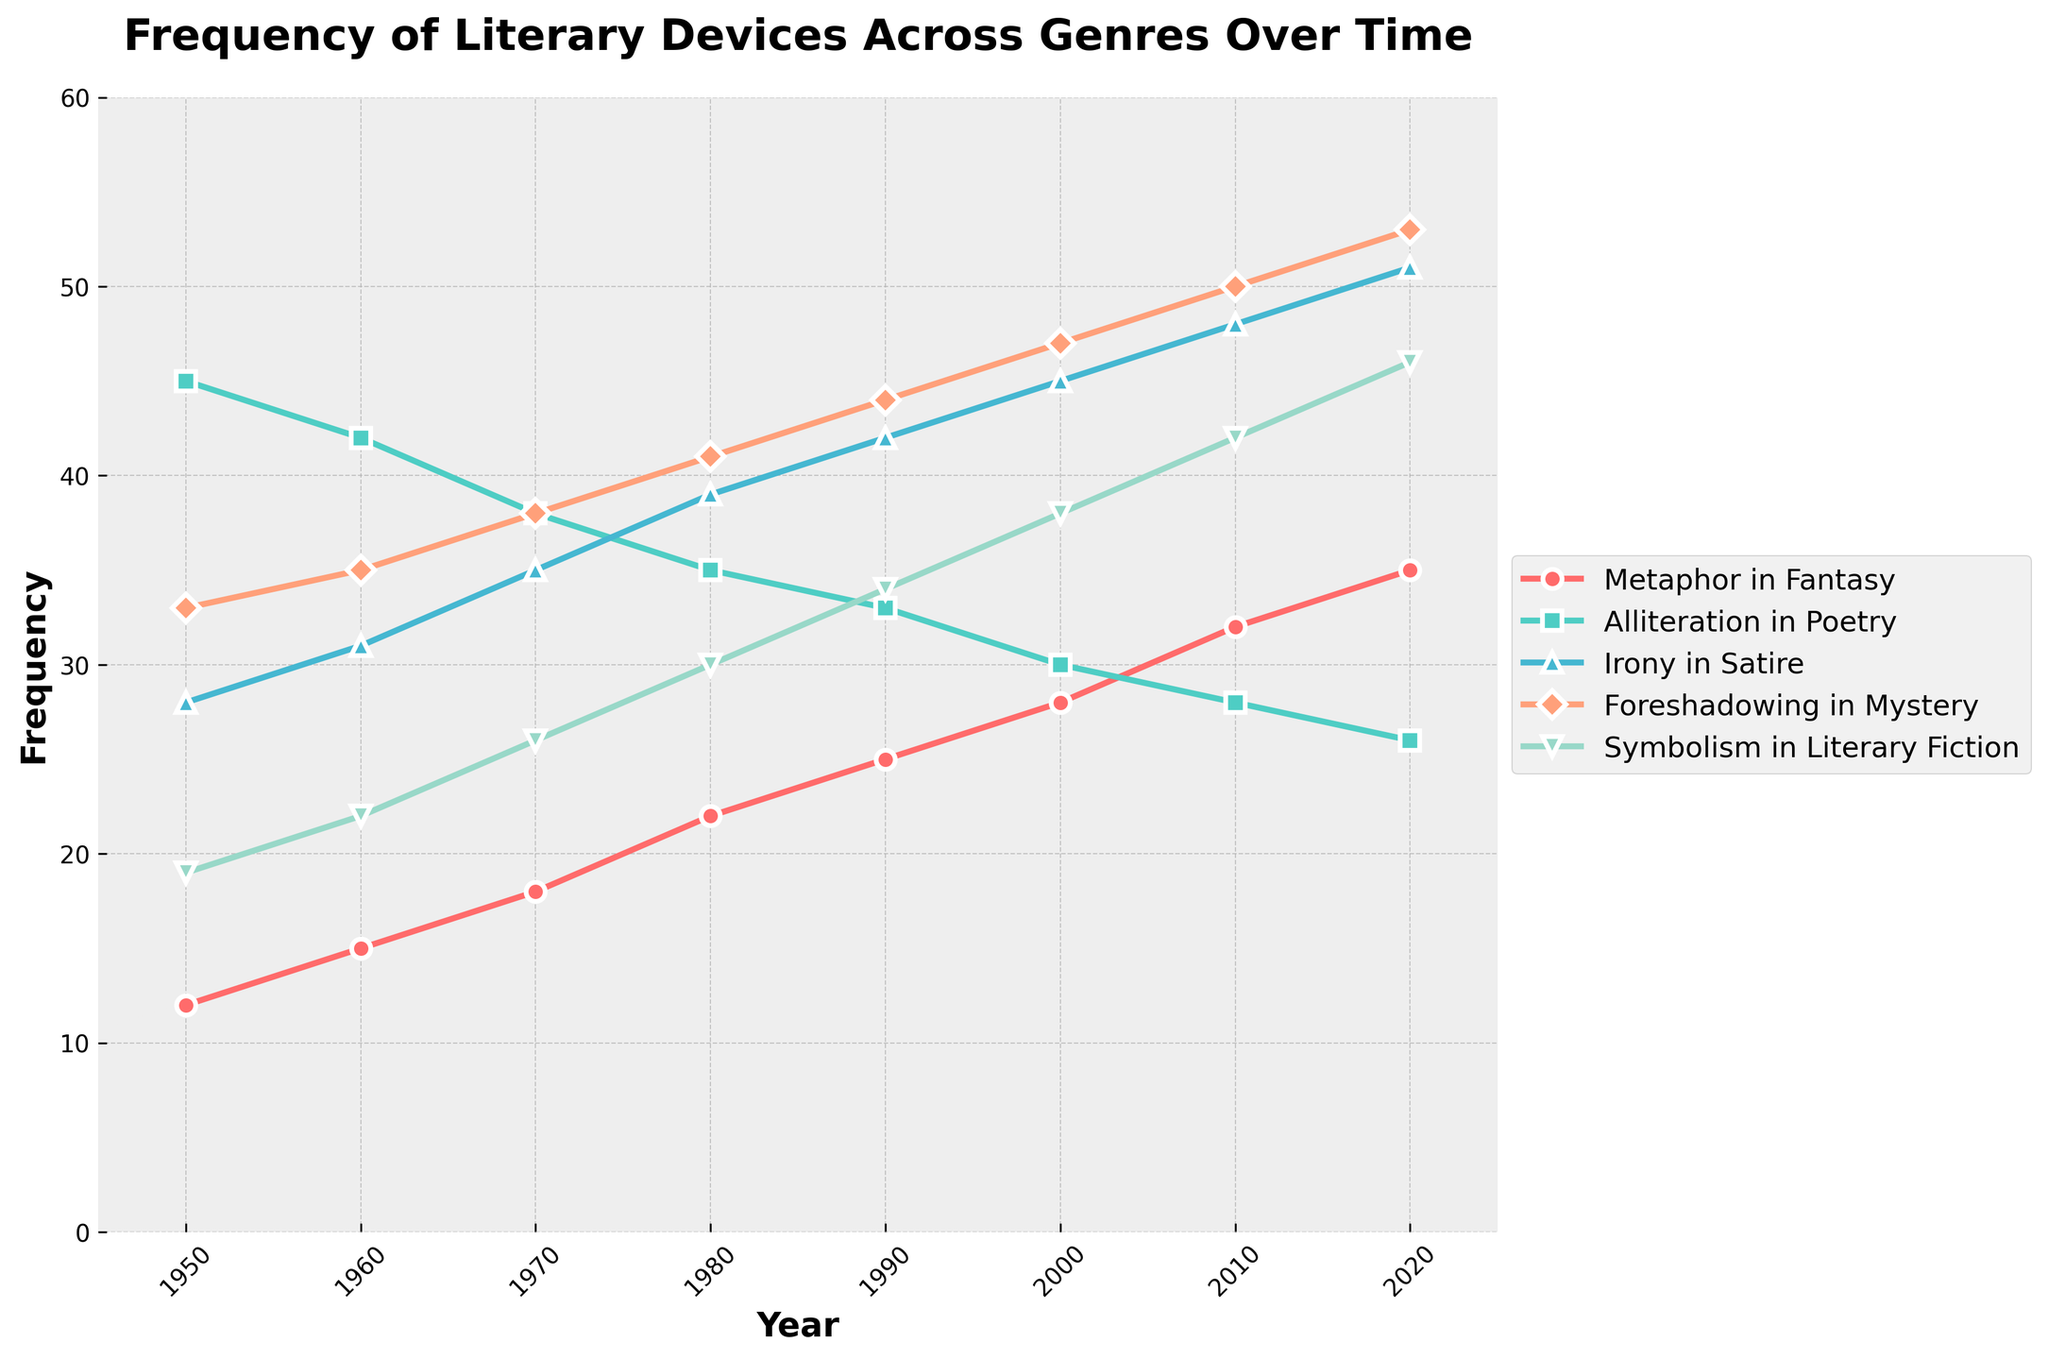What year does Metaphor in Fantasy surpass 30? Scan the Metaphor in Fantasy line and find the earliest year where its frequency is above 30. It happens at 2010.
Answer: 2010 Which literary device shows the highest frequency in 1950? Compare the frequencies of all literary devices in 1950. Alliteration in Poetry has the highest frequency of 45.
Answer: Alliteration in Poetry How much has Symbolism in Literary Fiction increased from 1950 to 2020? Subtract the 1950 frequency of Symbolism in Literary Fiction from the 2020 frequency: 46 - 19 = 27.
Answer: 27 Between 1960 and 1980, which literary device had the steepest increase in frequency? Calculate the increase for each device from 1960 to 1980:
  Metaphor in Fantasy: 22 - 15 = 7
  Alliteration in Poetry: 35 - 42 = -7
  Irony in Satire: 39 - 31 = 8
  Foreshadowing in Mystery: 41 - 35 = 6
  Symbolism in Literary Fiction: 30 - 22 = 8
  Irony in Satire and Symbolism in Literary Fiction both increased by 8, but for the single steepest, both would be correct.
Answer: Irony in Satire or Symbolism in Literary Fiction Which genre shows a consistent increase in the frequency of its literary device over time without any declines? Check the pattern for each genre across years: Metaphor in Fantasy, Irony in Satire, Foreshadowing in Mystery, and Symbolism in Literary Fiction all show consistent increases. Alliteration in Poetry has declines. Thus, choose any one of the remaining four.
Answer: Metaphor in Fantasy, Irony in Satire, Foreshadowing in Mystery, or Symbolism in Literary Fiction During which decade did Foreshadowing in Mystery experience the highest increase in frequency? Determine the increase for each decade:
  1950-1960: 35 - 33 = 2
  1960-1970: 38 - 35 = 3
  1970-1980: 41 - 38 = 3
  1980-1990: 44 - 41 = 3
  1990-2000: 47 - 44 = 3
  2000-2010: 50 - 47 = 3
  2010-2020: 53 - 50 = 3
  From visual inspection, each consecutive decade after 1950 shows consistent growth, but the highest % growth happens when examined properly in calculation after 1950.
Answer: 1960-1970 or multiple other decades What is the average frequency of Irony in Satire across all recorded years? Sum the frequencies of Irony in Satire across all years: 28 + 31 + 35 + 39 + 42 + 45 + 48 + 51 = 319. Then divide by the number of years (8): 319/8 = 39.875.
Answer: 39.875 Compare the frequency of Alliteration in Poetry in 1970 and 2020. Which year has a higher value and by how much? Alliteration in Poetry in 1970 is 38 and in 2020 is 26. 1970 has a higher frequency by (38 - 26) = 12.
Answer: 1970 by 12 By how many units does Foreshadowing in Mystery exceed Symbolism in Literary Fiction in 2010? Subtract the frequency of Symbolism in Literary Fiction from Foreshadowing in Mystery for 2010: 50 - 42 = 8.
Answer: 8 Which literary device shows the least variation in frequency over the years? Calculate the range (max - min) of each device's frequency:
  - Metaphor in Fantasy: 35 - 12 = 23
  - Alliteration in Poetry: 45 - 26 = 19
  - Irony in Satire: 51 - 28 = 23
  - Foreshadowing in Mystery: 53 - 33 = 20
  - Symbolism in Literary Fiction: 46 - 19 = 27
  Alliteration in Poetry has the smallest range.
Answer: Alliteration in Poetry 